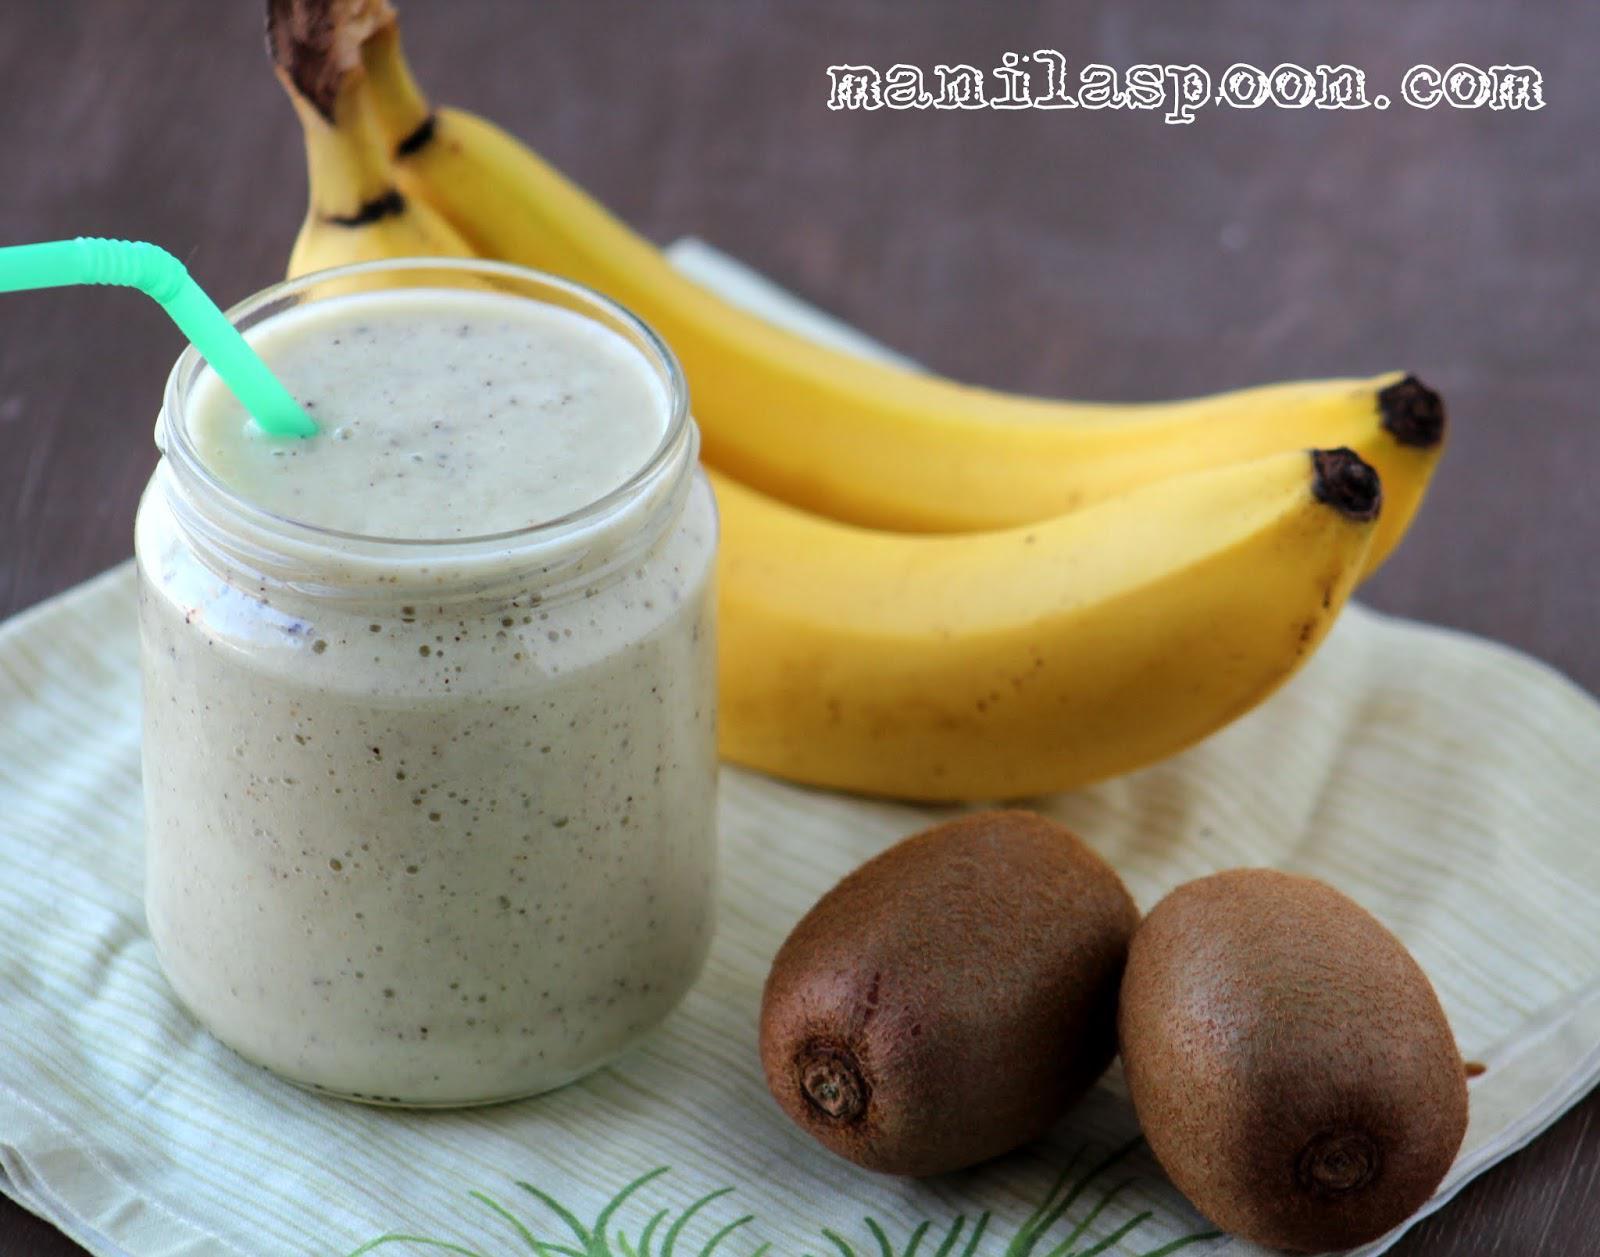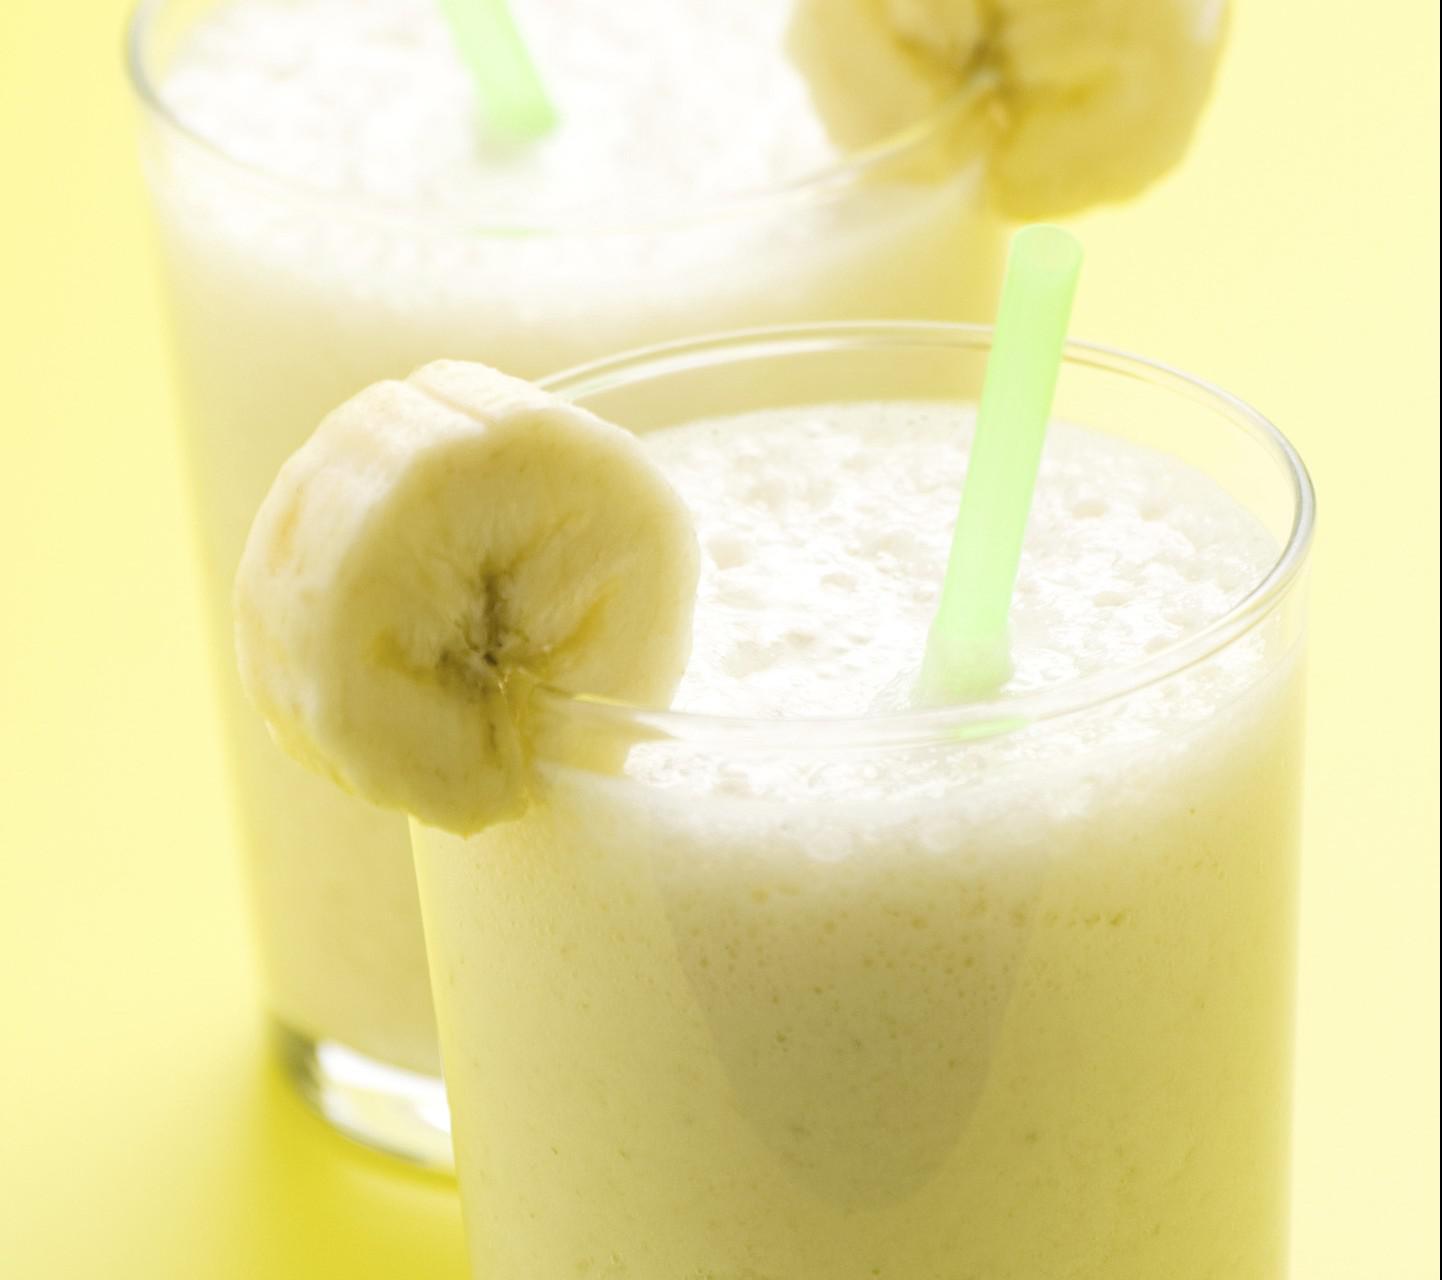The first image is the image on the left, the second image is the image on the right. Given the left and right images, does the statement "A glass containing a speckled green beverage is garnished with a kiwi fruit slice." hold true? Answer yes or no. No. The first image is the image on the left, the second image is the image on the right. Analyze the images presented: Is the assertion "One image shows chopped kiwi fruit, banana chunks, and lemon juice, while the second image includes a prepared green smoothie and cut kiwi fruit." valid? Answer yes or no. No. 